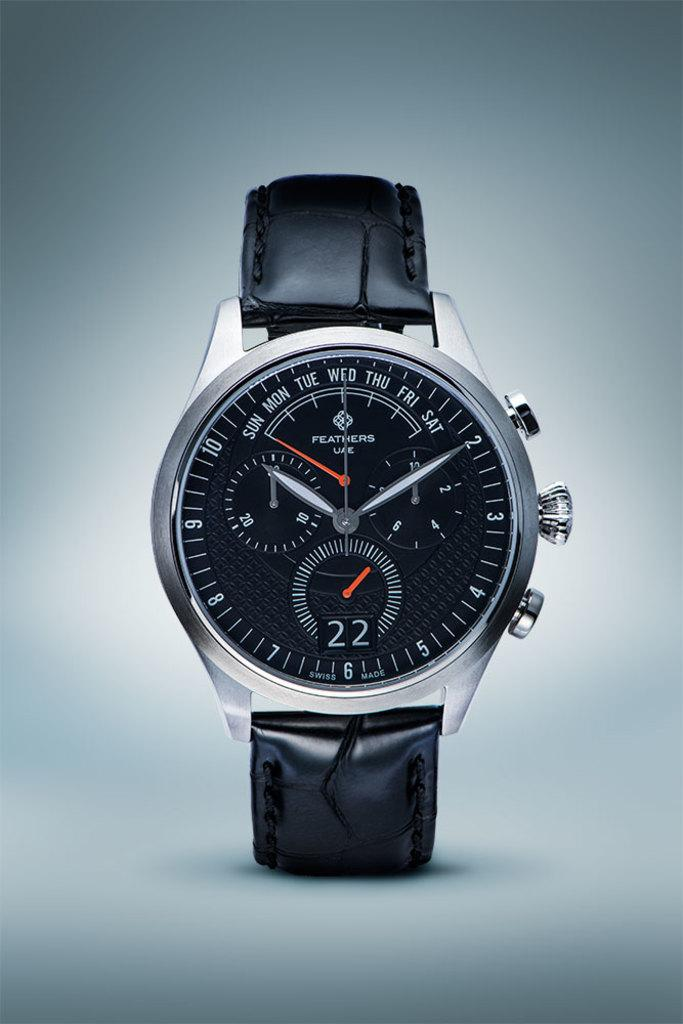<image>
Share a concise interpretation of the image provided. A Feathers brand watch with a black leather band on it. 